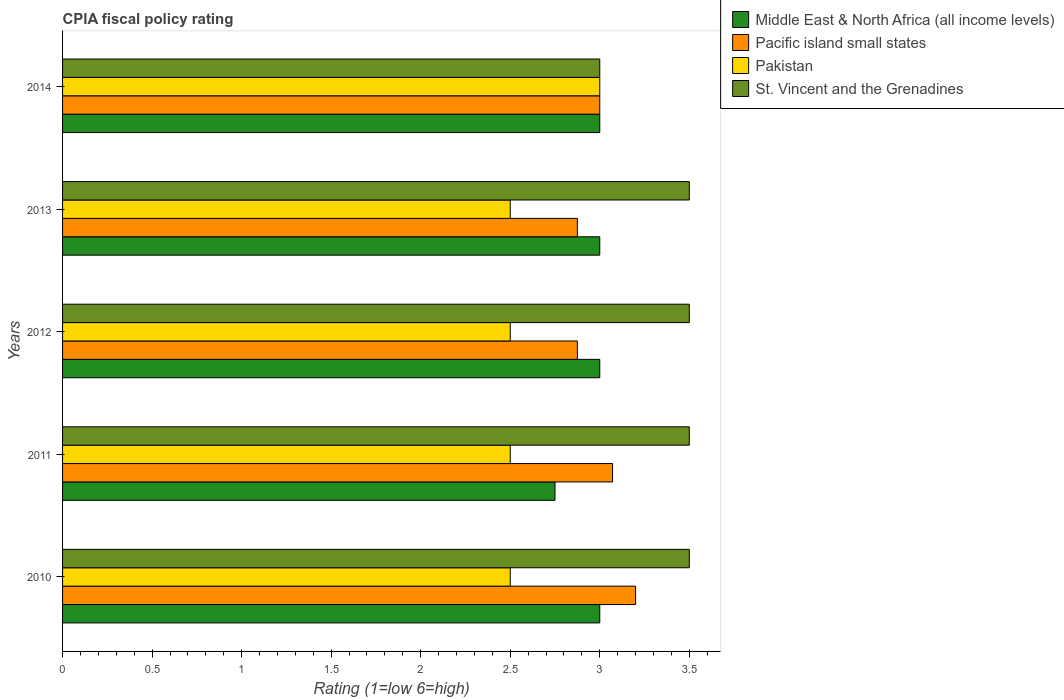How many different coloured bars are there?
Your answer should be very brief. 4. How many groups of bars are there?
Make the answer very short. 5. Are the number of bars per tick equal to the number of legend labels?
Make the answer very short. Yes. What is the label of the 3rd group of bars from the top?
Give a very brief answer. 2012. In how many cases, is the number of bars for a given year not equal to the number of legend labels?
Give a very brief answer. 0. Across all years, what is the maximum CPIA rating in Middle East & North Africa (all income levels)?
Ensure brevity in your answer.  3. Across all years, what is the minimum CPIA rating in Pacific island small states?
Keep it short and to the point. 2.88. What is the total CPIA rating in Pacific island small states in the graph?
Your answer should be very brief. 15.02. What is the difference between the CPIA rating in Pacific island small states in 2012 and that in 2013?
Make the answer very short. 0. What is the difference between the CPIA rating in St. Vincent and the Grenadines in 2013 and the CPIA rating in Pacific island small states in 2012?
Ensure brevity in your answer.  0.62. What is the average CPIA rating in St. Vincent and the Grenadines per year?
Offer a terse response. 3.4. In how many years, is the CPIA rating in Pacific island small states greater than 1.6 ?
Ensure brevity in your answer.  5. What is the ratio of the CPIA rating in Pacific island small states in 2012 to that in 2014?
Provide a short and direct response. 0.96. Is the CPIA rating in Pacific island small states in 2012 less than that in 2014?
Ensure brevity in your answer.  Yes. What is the difference between the highest and the second highest CPIA rating in Pakistan?
Make the answer very short. 0.5. What does the 1st bar from the top in 2014 represents?
Give a very brief answer. St. Vincent and the Grenadines. What does the 3rd bar from the bottom in 2010 represents?
Make the answer very short. Pakistan. How many bars are there?
Ensure brevity in your answer.  20. Are all the bars in the graph horizontal?
Provide a succinct answer. Yes. What is the difference between two consecutive major ticks on the X-axis?
Give a very brief answer. 0.5. Are the values on the major ticks of X-axis written in scientific E-notation?
Your answer should be very brief. No. How many legend labels are there?
Provide a succinct answer. 4. What is the title of the graph?
Keep it short and to the point. CPIA fiscal policy rating. Does "Virgin Islands" appear as one of the legend labels in the graph?
Make the answer very short. No. What is the label or title of the Y-axis?
Offer a very short reply. Years. What is the Rating (1=low 6=high) in St. Vincent and the Grenadines in 2010?
Keep it short and to the point. 3.5. What is the Rating (1=low 6=high) of Middle East & North Africa (all income levels) in 2011?
Keep it short and to the point. 2.75. What is the Rating (1=low 6=high) of Pacific island small states in 2011?
Give a very brief answer. 3.07. What is the Rating (1=low 6=high) of Pakistan in 2011?
Your answer should be very brief. 2.5. What is the Rating (1=low 6=high) in St. Vincent and the Grenadines in 2011?
Provide a short and direct response. 3.5. What is the Rating (1=low 6=high) in Pacific island small states in 2012?
Offer a terse response. 2.88. What is the Rating (1=low 6=high) of Pakistan in 2012?
Give a very brief answer. 2.5. What is the Rating (1=low 6=high) in St. Vincent and the Grenadines in 2012?
Provide a short and direct response. 3.5. What is the Rating (1=low 6=high) of Pacific island small states in 2013?
Your answer should be very brief. 2.88. What is the Rating (1=low 6=high) of Pakistan in 2013?
Provide a short and direct response. 2.5. What is the Rating (1=low 6=high) in Pacific island small states in 2014?
Offer a very short reply. 3. What is the Rating (1=low 6=high) of Pakistan in 2014?
Provide a short and direct response. 3. Across all years, what is the maximum Rating (1=low 6=high) of Middle East & North Africa (all income levels)?
Your response must be concise. 3. Across all years, what is the maximum Rating (1=low 6=high) of Pacific island small states?
Your answer should be very brief. 3.2. Across all years, what is the maximum Rating (1=low 6=high) of Pakistan?
Your response must be concise. 3. Across all years, what is the maximum Rating (1=low 6=high) in St. Vincent and the Grenadines?
Give a very brief answer. 3.5. Across all years, what is the minimum Rating (1=low 6=high) in Middle East & North Africa (all income levels)?
Ensure brevity in your answer.  2.75. Across all years, what is the minimum Rating (1=low 6=high) in Pacific island small states?
Give a very brief answer. 2.88. Across all years, what is the minimum Rating (1=low 6=high) of Pakistan?
Make the answer very short. 2.5. Across all years, what is the minimum Rating (1=low 6=high) in St. Vincent and the Grenadines?
Provide a succinct answer. 3. What is the total Rating (1=low 6=high) in Middle East & North Africa (all income levels) in the graph?
Give a very brief answer. 14.75. What is the total Rating (1=low 6=high) in Pacific island small states in the graph?
Provide a short and direct response. 15.02. What is the total Rating (1=low 6=high) in St. Vincent and the Grenadines in the graph?
Make the answer very short. 17. What is the difference between the Rating (1=low 6=high) in Middle East & North Africa (all income levels) in 2010 and that in 2011?
Ensure brevity in your answer.  0.25. What is the difference between the Rating (1=low 6=high) of Pacific island small states in 2010 and that in 2011?
Make the answer very short. 0.13. What is the difference between the Rating (1=low 6=high) in Pakistan in 2010 and that in 2011?
Give a very brief answer. 0. What is the difference between the Rating (1=low 6=high) of St. Vincent and the Grenadines in 2010 and that in 2011?
Make the answer very short. 0. What is the difference between the Rating (1=low 6=high) of Middle East & North Africa (all income levels) in 2010 and that in 2012?
Provide a succinct answer. 0. What is the difference between the Rating (1=low 6=high) of Pacific island small states in 2010 and that in 2012?
Keep it short and to the point. 0.33. What is the difference between the Rating (1=low 6=high) in Pacific island small states in 2010 and that in 2013?
Provide a succinct answer. 0.33. What is the difference between the Rating (1=low 6=high) in Pakistan in 2010 and that in 2013?
Your answer should be very brief. 0. What is the difference between the Rating (1=low 6=high) in St. Vincent and the Grenadines in 2010 and that in 2013?
Provide a short and direct response. 0. What is the difference between the Rating (1=low 6=high) in Pacific island small states in 2011 and that in 2012?
Keep it short and to the point. 0.2. What is the difference between the Rating (1=low 6=high) in Pakistan in 2011 and that in 2012?
Give a very brief answer. 0. What is the difference between the Rating (1=low 6=high) of St. Vincent and the Grenadines in 2011 and that in 2012?
Ensure brevity in your answer.  0. What is the difference between the Rating (1=low 6=high) of Middle East & North Africa (all income levels) in 2011 and that in 2013?
Your answer should be very brief. -0.25. What is the difference between the Rating (1=low 6=high) of Pacific island small states in 2011 and that in 2013?
Provide a succinct answer. 0.2. What is the difference between the Rating (1=low 6=high) of Pakistan in 2011 and that in 2013?
Keep it short and to the point. 0. What is the difference between the Rating (1=low 6=high) of St. Vincent and the Grenadines in 2011 and that in 2013?
Provide a short and direct response. 0. What is the difference between the Rating (1=low 6=high) in Middle East & North Africa (all income levels) in 2011 and that in 2014?
Your answer should be very brief. -0.25. What is the difference between the Rating (1=low 6=high) in Pacific island small states in 2011 and that in 2014?
Your answer should be compact. 0.07. What is the difference between the Rating (1=low 6=high) in Pakistan in 2011 and that in 2014?
Ensure brevity in your answer.  -0.5. What is the difference between the Rating (1=low 6=high) in Middle East & North Africa (all income levels) in 2012 and that in 2013?
Your response must be concise. 0. What is the difference between the Rating (1=low 6=high) in Pakistan in 2012 and that in 2013?
Provide a succinct answer. 0. What is the difference between the Rating (1=low 6=high) in Middle East & North Africa (all income levels) in 2012 and that in 2014?
Offer a very short reply. 0. What is the difference between the Rating (1=low 6=high) of Pacific island small states in 2012 and that in 2014?
Your answer should be compact. -0.12. What is the difference between the Rating (1=low 6=high) of Middle East & North Africa (all income levels) in 2013 and that in 2014?
Offer a very short reply. 0. What is the difference between the Rating (1=low 6=high) in Pacific island small states in 2013 and that in 2014?
Keep it short and to the point. -0.12. What is the difference between the Rating (1=low 6=high) in St. Vincent and the Grenadines in 2013 and that in 2014?
Make the answer very short. 0.5. What is the difference between the Rating (1=low 6=high) of Middle East & North Africa (all income levels) in 2010 and the Rating (1=low 6=high) of Pacific island small states in 2011?
Ensure brevity in your answer.  -0.07. What is the difference between the Rating (1=low 6=high) of Middle East & North Africa (all income levels) in 2010 and the Rating (1=low 6=high) of Pakistan in 2011?
Offer a terse response. 0.5. What is the difference between the Rating (1=low 6=high) of Pacific island small states in 2010 and the Rating (1=low 6=high) of St. Vincent and the Grenadines in 2011?
Your response must be concise. -0.3. What is the difference between the Rating (1=low 6=high) of Middle East & North Africa (all income levels) in 2010 and the Rating (1=low 6=high) of St. Vincent and the Grenadines in 2012?
Provide a succinct answer. -0.5. What is the difference between the Rating (1=low 6=high) in Pacific island small states in 2010 and the Rating (1=low 6=high) in St. Vincent and the Grenadines in 2012?
Offer a terse response. -0.3. What is the difference between the Rating (1=low 6=high) of Middle East & North Africa (all income levels) in 2010 and the Rating (1=low 6=high) of Pacific island small states in 2013?
Your answer should be compact. 0.12. What is the difference between the Rating (1=low 6=high) in Pacific island small states in 2010 and the Rating (1=low 6=high) in St. Vincent and the Grenadines in 2013?
Provide a short and direct response. -0.3. What is the difference between the Rating (1=low 6=high) in Middle East & North Africa (all income levels) in 2010 and the Rating (1=low 6=high) in St. Vincent and the Grenadines in 2014?
Ensure brevity in your answer.  0. What is the difference between the Rating (1=low 6=high) in Pacific island small states in 2010 and the Rating (1=low 6=high) in Pakistan in 2014?
Provide a short and direct response. 0.2. What is the difference between the Rating (1=low 6=high) of Middle East & North Africa (all income levels) in 2011 and the Rating (1=low 6=high) of Pacific island small states in 2012?
Your response must be concise. -0.12. What is the difference between the Rating (1=low 6=high) of Middle East & North Africa (all income levels) in 2011 and the Rating (1=low 6=high) of St. Vincent and the Grenadines in 2012?
Keep it short and to the point. -0.75. What is the difference between the Rating (1=low 6=high) of Pacific island small states in 2011 and the Rating (1=low 6=high) of Pakistan in 2012?
Your response must be concise. 0.57. What is the difference between the Rating (1=low 6=high) of Pacific island small states in 2011 and the Rating (1=low 6=high) of St. Vincent and the Grenadines in 2012?
Keep it short and to the point. -0.43. What is the difference between the Rating (1=low 6=high) in Pakistan in 2011 and the Rating (1=low 6=high) in St. Vincent and the Grenadines in 2012?
Provide a short and direct response. -1. What is the difference between the Rating (1=low 6=high) in Middle East & North Africa (all income levels) in 2011 and the Rating (1=low 6=high) in Pacific island small states in 2013?
Provide a short and direct response. -0.12. What is the difference between the Rating (1=low 6=high) in Middle East & North Africa (all income levels) in 2011 and the Rating (1=low 6=high) in Pakistan in 2013?
Your answer should be very brief. 0.25. What is the difference between the Rating (1=low 6=high) of Middle East & North Africa (all income levels) in 2011 and the Rating (1=low 6=high) of St. Vincent and the Grenadines in 2013?
Offer a terse response. -0.75. What is the difference between the Rating (1=low 6=high) in Pacific island small states in 2011 and the Rating (1=low 6=high) in St. Vincent and the Grenadines in 2013?
Make the answer very short. -0.43. What is the difference between the Rating (1=low 6=high) of Pakistan in 2011 and the Rating (1=low 6=high) of St. Vincent and the Grenadines in 2013?
Your response must be concise. -1. What is the difference between the Rating (1=low 6=high) in Middle East & North Africa (all income levels) in 2011 and the Rating (1=low 6=high) in Pakistan in 2014?
Provide a short and direct response. -0.25. What is the difference between the Rating (1=low 6=high) of Pacific island small states in 2011 and the Rating (1=low 6=high) of Pakistan in 2014?
Your response must be concise. 0.07. What is the difference between the Rating (1=low 6=high) in Pacific island small states in 2011 and the Rating (1=low 6=high) in St. Vincent and the Grenadines in 2014?
Offer a very short reply. 0.07. What is the difference between the Rating (1=low 6=high) in Middle East & North Africa (all income levels) in 2012 and the Rating (1=low 6=high) in Pacific island small states in 2013?
Give a very brief answer. 0.12. What is the difference between the Rating (1=low 6=high) of Middle East & North Africa (all income levels) in 2012 and the Rating (1=low 6=high) of Pakistan in 2013?
Provide a succinct answer. 0.5. What is the difference between the Rating (1=low 6=high) in Pacific island small states in 2012 and the Rating (1=low 6=high) in Pakistan in 2013?
Give a very brief answer. 0.38. What is the difference between the Rating (1=low 6=high) of Pacific island small states in 2012 and the Rating (1=low 6=high) of St. Vincent and the Grenadines in 2013?
Your answer should be compact. -0.62. What is the difference between the Rating (1=low 6=high) in Middle East & North Africa (all income levels) in 2012 and the Rating (1=low 6=high) in St. Vincent and the Grenadines in 2014?
Keep it short and to the point. 0. What is the difference between the Rating (1=low 6=high) in Pacific island small states in 2012 and the Rating (1=low 6=high) in Pakistan in 2014?
Keep it short and to the point. -0.12. What is the difference between the Rating (1=low 6=high) in Pacific island small states in 2012 and the Rating (1=low 6=high) in St. Vincent and the Grenadines in 2014?
Your response must be concise. -0.12. What is the difference between the Rating (1=low 6=high) in Pakistan in 2012 and the Rating (1=low 6=high) in St. Vincent and the Grenadines in 2014?
Keep it short and to the point. -0.5. What is the difference between the Rating (1=low 6=high) in Middle East & North Africa (all income levels) in 2013 and the Rating (1=low 6=high) in Pacific island small states in 2014?
Offer a very short reply. 0. What is the difference between the Rating (1=low 6=high) in Pacific island small states in 2013 and the Rating (1=low 6=high) in Pakistan in 2014?
Give a very brief answer. -0.12. What is the difference between the Rating (1=low 6=high) of Pacific island small states in 2013 and the Rating (1=low 6=high) of St. Vincent and the Grenadines in 2014?
Keep it short and to the point. -0.12. What is the difference between the Rating (1=low 6=high) of Pakistan in 2013 and the Rating (1=low 6=high) of St. Vincent and the Grenadines in 2014?
Keep it short and to the point. -0.5. What is the average Rating (1=low 6=high) of Middle East & North Africa (all income levels) per year?
Give a very brief answer. 2.95. What is the average Rating (1=low 6=high) in Pacific island small states per year?
Your answer should be very brief. 3. What is the average Rating (1=low 6=high) in Pakistan per year?
Make the answer very short. 2.6. In the year 2010, what is the difference between the Rating (1=low 6=high) in Middle East & North Africa (all income levels) and Rating (1=low 6=high) in Pacific island small states?
Provide a succinct answer. -0.2. In the year 2010, what is the difference between the Rating (1=low 6=high) in Middle East & North Africa (all income levels) and Rating (1=low 6=high) in Pakistan?
Your answer should be compact. 0.5. In the year 2010, what is the difference between the Rating (1=low 6=high) of Middle East & North Africa (all income levels) and Rating (1=low 6=high) of St. Vincent and the Grenadines?
Provide a succinct answer. -0.5. In the year 2010, what is the difference between the Rating (1=low 6=high) in Pacific island small states and Rating (1=low 6=high) in Pakistan?
Offer a very short reply. 0.7. In the year 2010, what is the difference between the Rating (1=low 6=high) in Pacific island small states and Rating (1=low 6=high) in St. Vincent and the Grenadines?
Your answer should be compact. -0.3. In the year 2011, what is the difference between the Rating (1=low 6=high) of Middle East & North Africa (all income levels) and Rating (1=low 6=high) of Pacific island small states?
Give a very brief answer. -0.32. In the year 2011, what is the difference between the Rating (1=low 6=high) in Middle East & North Africa (all income levels) and Rating (1=low 6=high) in Pakistan?
Provide a short and direct response. 0.25. In the year 2011, what is the difference between the Rating (1=low 6=high) of Middle East & North Africa (all income levels) and Rating (1=low 6=high) of St. Vincent and the Grenadines?
Ensure brevity in your answer.  -0.75. In the year 2011, what is the difference between the Rating (1=low 6=high) in Pacific island small states and Rating (1=low 6=high) in St. Vincent and the Grenadines?
Give a very brief answer. -0.43. In the year 2011, what is the difference between the Rating (1=low 6=high) in Pakistan and Rating (1=low 6=high) in St. Vincent and the Grenadines?
Your answer should be compact. -1. In the year 2012, what is the difference between the Rating (1=low 6=high) of Middle East & North Africa (all income levels) and Rating (1=low 6=high) of Pakistan?
Offer a terse response. 0.5. In the year 2012, what is the difference between the Rating (1=low 6=high) in Pacific island small states and Rating (1=low 6=high) in St. Vincent and the Grenadines?
Your answer should be very brief. -0.62. In the year 2012, what is the difference between the Rating (1=low 6=high) of Pakistan and Rating (1=low 6=high) of St. Vincent and the Grenadines?
Your response must be concise. -1. In the year 2013, what is the difference between the Rating (1=low 6=high) of Middle East & North Africa (all income levels) and Rating (1=low 6=high) of Pakistan?
Offer a very short reply. 0.5. In the year 2013, what is the difference between the Rating (1=low 6=high) in Pacific island small states and Rating (1=low 6=high) in St. Vincent and the Grenadines?
Give a very brief answer. -0.62. In the year 2013, what is the difference between the Rating (1=low 6=high) in Pakistan and Rating (1=low 6=high) in St. Vincent and the Grenadines?
Your response must be concise. -1. In the year 2014, what is the difference between the Rating (1=low 6=high) in Middle East & North Africa (all income levels) and Rating (1=low 6=high) in Pacific island small states?
Offer a very short reply. 0. In the year 2014, what is the difference between the Rating (1=low 6=high) in Pacific island small states and Rating (1=low 6=high) in St. Vincent and the Grenadines?
Offer a very short reply. 0. In the year 2014, what is the difference between the Rating (1=low 6=high) of Pakistan and Rating (1=low 6=high) of St. Vincent and the Grenadines?
Offer a very short reply. 0. What is the ratio of the Rating (1=low 6=high) in Pacific island small states in 2010 to that in 2011?
Your answer should be compact. 1.04. What is the ratio of the Rating (1=low 6=high) of Pakistan in 2010 to that in 2011?
Your answer should be very brief. 1. What is the ratio of the Rating (1=low 6=high) of St. Vincent and the Grenadines in 2010 to that in 2011?
Your answer should be compact. 1. What is the ratio of the Rating (1=low 6=high) of Middle East & North Africa (all income levels) in 2010 to that in 2012?
Offer a terse response. 1. What is the ratio of the Rating (1=low 6=high) in Pacific island small states in 2010 to that in 2012?
Your answer should be very brief. 1.11. What is the ratio of the Rating (1=low 6=high) of Pakistan in 2010 to that in 2012?
Your answer should be compact. 1. What is the ratio of the Rating (1=low 6=high) of Pacific island small states in 2010 to that in 2013?
Provide a succinct answer. 1.11. What is the ratio of the Rating (1=low 6=high) of Pakistan in 2010 to that in 2013?
Make the answer very short. 1. What is the ratio of the Rating (1=low 6=high) in St. Vincent and the Grenadines in 2010 to that in 2013?
Ensure brevity in your answer.  1. What is the ratio of the Rating (1=low 6=high) of Pacific island small states in 2010 to that in 2014?
Give a very brief answer. 1.07. What is the ratio of the Rating (1=low 6=high) of St. Vincent and the Grenadines in 2010 to that in 2014?
Your answer should be compact. 1.17. What is the ratio of the Rating (1=low 6=high) of Pacific island small states in 2011 to that in 2012?
Keep it short and to the point. 1.07. What is the ratio of the Rating (1=low 6=high) of Pacific island small states in 2011 to that in 2013?
Keep it short and to the point. 1.07. What is the ratio of the Rating (1=low 6=high) of St. Vincent and the Grenadines in 2011 to that in 2013?
Ensure brevity in your answer.  1. What is the ratio of the Rating (1=low 6=high) of Middle East & North Africa (all income levels) in 2011 to that in 2014?
Keep it short and to the point. 0.92. What is the ratio of the Rating (1=low 6=high) of Pacific island small states in 2011 to that in 2014?
Provide a short and direct response. 1.02. What is the ratio of the Rating (1=low 6=high) of Middle East & North Africa (all income levels) in 2012 to that in 2013?
Your answer should be very brief. 1. What is the ratio of the Rating (1=low 6=high) of Pacific island small states in 2012 to that in 2013?
Your answer should be very brief. 1. What is the ratio of the Rating (1=low 6=high) in Pakistan in 2012 to that in 2013?
Give a very brief answer. 1. What is the ratio of the Rating (1=low 6=high) in Pakistan in 2012 to that in 2014?
Your response must be concise. 0.83. What is the ratio of the Rating (1=low 6=high) of St. Vincent and the Grenadines in 2012 to that in 2014?
Your answer should be compact. 1.17. What is the ratio of the Rating (1=low 6=high) in Middle East & North Africa (all income levels) in 2013 to that in 2014?
Provide a succinct answer. 1. What is the ratio of the Rating (1=low 6=high) in Pakistan in 2013 to that in 2014?
Give a very brief answer. 0.83. What is the ratio of the Rating (1=low 6=high) of St. Vincent and the Grenadines in 2013 to that in 2014?
Provide a short and direct response. 1.17. What is the difference between the highest and the second highest Rating (1=low 6=high) of Pacific island small states?
Make the answer very short. 0.13. What is the difference between the highest and the second highest Rating (1=low 6=high) of St. Vincent and the Grenadines?
Provide a short and direct response. 0. What is the difference between the highest and the lowest Rating (1=low 6=high) of Middle East & North Africa (all income levels)?
Make the answer very short. 0.25. What is the difference between the highest and the lowest Rating (1=low 6=high) of Pacific island small states?
Provide a succinct answer. 0.33. What is the difference between the highest and the lowest Rating (1=low 6=high) of Pakistan?
Your answer should be compact. 0.5. 